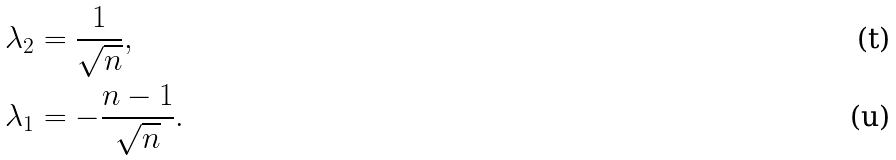<formula> <loc_0><loc_0><loc_500><loc_500>& \lambda _ { 2 } = \frac { 1 } { \sqrt { n } } , \\ & \lambda _ { 1 } = - \frac { n - 1 } { \sqrt { n } } .</formula> 